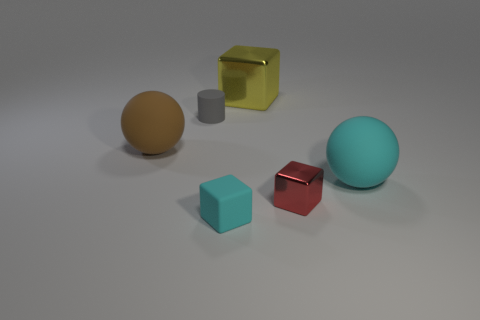Add 4 yellow matte objects. How many objects exist? 10 Subtract all big yellow cubes. How many cubes are left? 2 Subtract all brown spheres. How many red blocks are left? 1 Subtract all cyan balls. How many balls are left? 1 Subtract 0 yellow cylinders. How many objects are left? 6 Subtract all balls. How many objects are left? 4 Subtract 1 spheres. How many spheres are left? 1 Subtract all brown spheres. Subtract all blue blocks. How many spheres are left? 1 Subtract all red metallic blocks. Subtract all red objects. How many objects are left? 4 Add 6 small red objects. How many small red objects are left? 7 